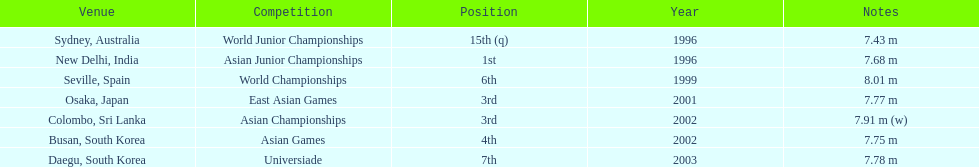In what year was the position of 3rd first achieved? 2001. 